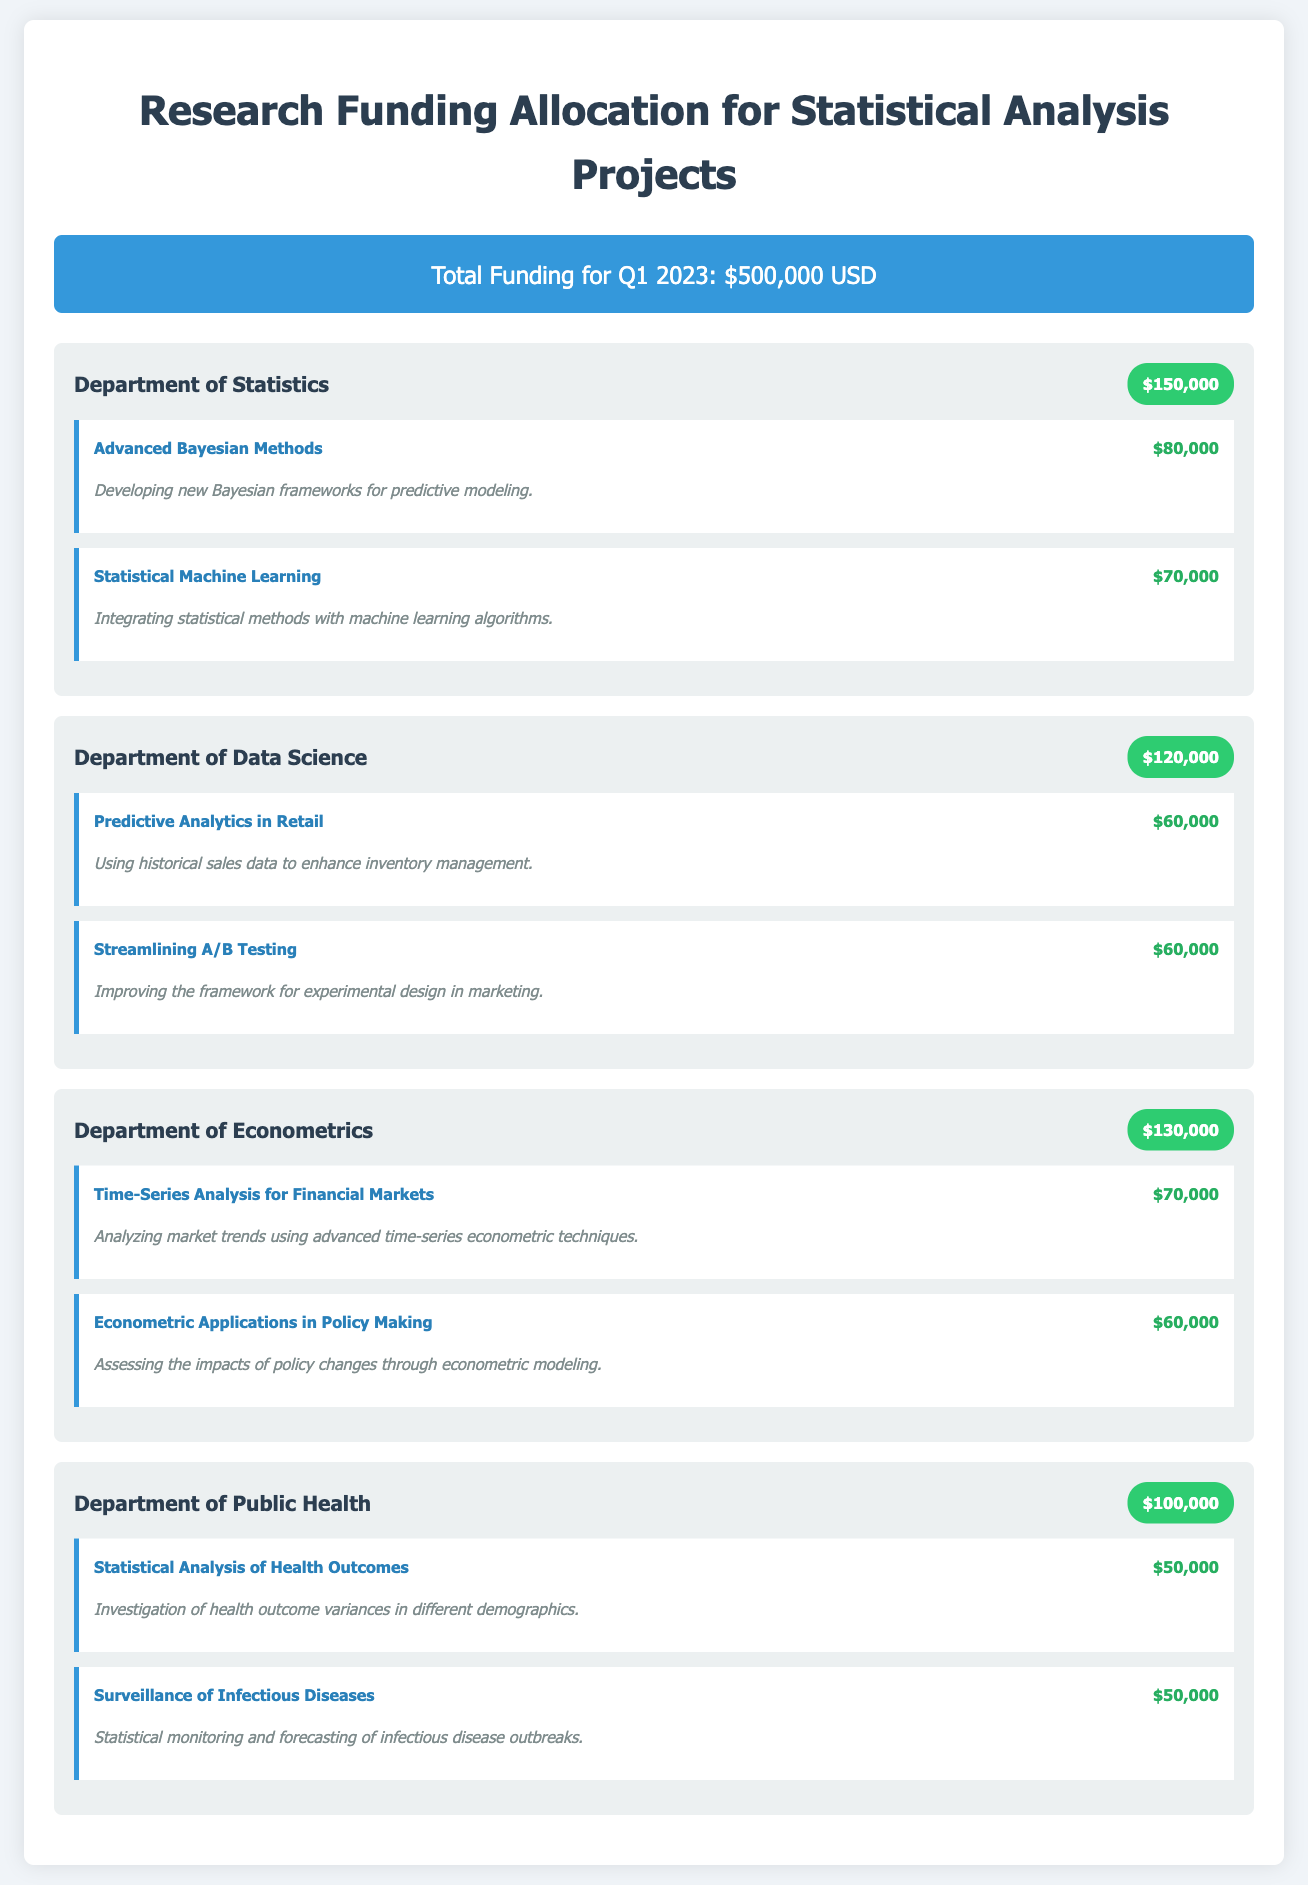What is the total funding for Q1 2023? The total funding for Q1 2023 is stated at the top of the document.
Answer: $500,000 USD Which department received the highest funding? The department with the highest funding can be identified by comparing the funding amounts for each department.
Answer: Department of Econometrics How much funding is allocated to the Department of Public Health? The funding amount is specified in the department header for Public Health.
Answer: $100,000 What is the budget for the project "Advanced Bayesian Methods"? The budget for this specific project is listed in its project header.
Answer: $80,000 Which project focuses on "Statistical Monitoring and Forecasting of Infectious Disease Outbreaks"? The project name can be identified in the Department of Public Health section.
Answer: Surveillance of Infectious Diseases What is the total funding allocated to the Department of Data Science? The total funding for Data Science is found in the department header.
Answer: $120,000 How many projects are listed under the Department of Statistics? The number of projects under each department can be counted from the document content.
Answer: 2 What project has a funding budget of $60,000 in the Department of Econometrics? The project with this budget can be found in the Econometrics section; it's mentioned in the project details.
Answer: Econometric Applications in Policy Making What is the total funding for projects in the Department of Public Health? The total can be calculated by summing the budgets of the two projects listed.
Answer: $100,000 